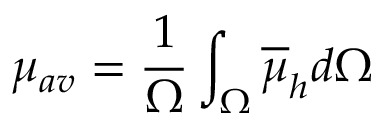Convert formula to latex. <formula><loc_0><loc_0><loc_500><loc_500>\mu _ { a v } = \frac { 1 } { \Omega } \int _ { \Omega } \overline { \mu } _ { h } d \Omega</formula> 